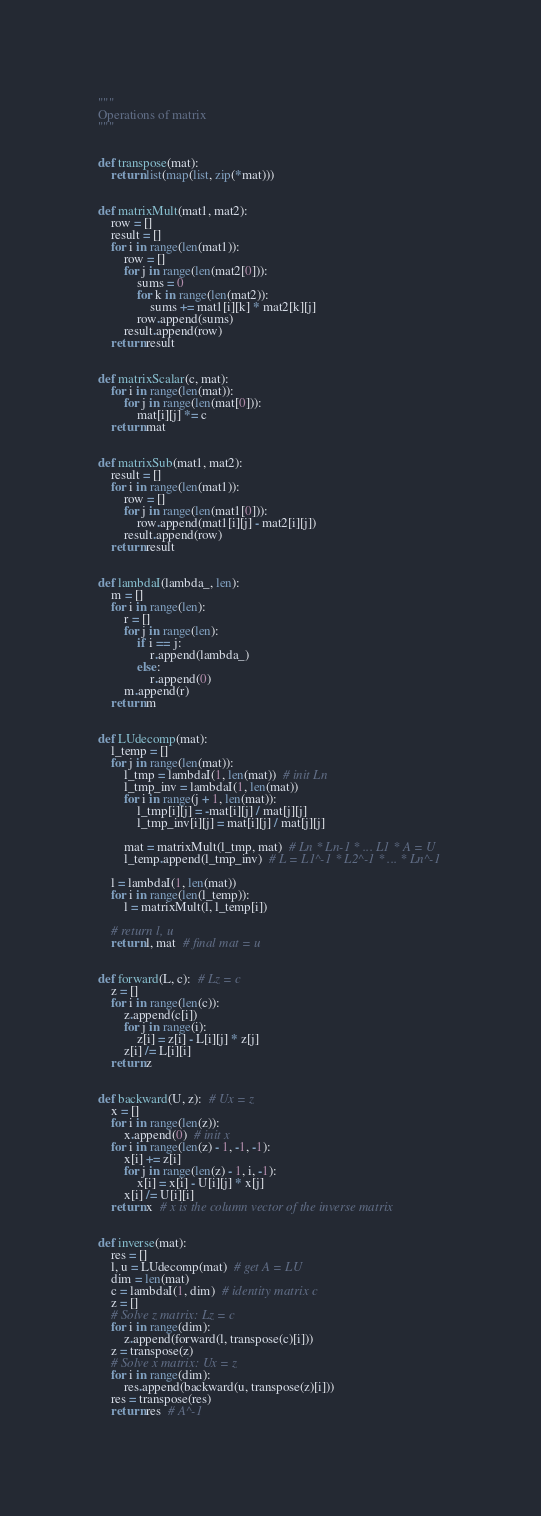<code> <loc_0><loc_0><loc_500><loc_500><_Python_>"""
Operations of matrix
"""


def transpose(mat):
    return list(map(list, zip(*mat)))


def matrixMult(mat1, mat2):
    row = []
    result = []
    for i in range(len(mat1)):
        row = []
        for j in range(len(mat2[0])):
            sums = 0
            for k in range(len(mat2)):
                sums += mat1[i][k] * mat2[k][j]
            row.append(sums)
        result.append(row)
    return result


def matrixScalar(c, mat):
    for i in range(len(mat)):
        for j in range(len(mat[0])):
            mat[i][j] *= c
    return mat


def matrixSub(mat1, mat2):
    result = []
    for i in range(len(mat1)):
        row = []
        for j in range(len(mat1[0])):
            row.append(mat1[i][j] - mat2[i][j])
        result.append(row)
    return result


def lambdaI(lambda_, len):
    m = []
    for i in range(len):
        r = []
        for j in range(len):
            if i == j:
                r.append(lambda_)
            else:
                r.append(0)
        m.append(r)
    return m


def LUdecomp(mat):
    l_temp = []
    for j in range(len(mat)):
        l_tmp = lambdaI(1, len(mat))  # init Ln
        l_tmp_inv = lambdaI(1, len(mat))
        for i in range(j + 1, len(mat)):
            l_tmp[i][j] = -mat[i][j] / mat[j][j]
            l_tmp_inv[i][j] = mat[i][j] / mat[j][j]

        mat = matrixMult(l_tmp, mat)  # Ln * Ln-1 * ... L1 * A = U
        l_temp.append(l_tmp_inv)  # L = L1^-1 * L2^-1 * ... * Ln^-1

    l = lambdaI(1, len(mat))
    for i in range(len(l_temp)):
        l = matrixMult(l, l_temp[i])

    # return l, u
    return l, mat  # final mat = u


def forward(L, c):  # Lz = c
    z = []
    for i in range(len(c)):
        z.append(c[i])
        for j in range(i):
            z[i] = z[i] - L[i][j] * z[j]
        z[i] /= L[i][i]
    return z


def backward(U, z):  # Ux = z
    x = []
    for i in range(len(z)):
        x.append(0)  # init x
    for i in range(len(z) - 1, -1, -1):
        x[i] += z[i]
        for j in range(len(z) - 1, i, -1):
            x[i] = x[i] - U[i][j] * x[j]
        x[i] /= U[i][i]
    return x  # x is the column vector of the inverse matrix


def inverse(mat):
    res = []
    l, u = LUdecomp(mat)  # get A = LU
    dim = len(mat)
    c = lambdaI(1, dim)  # identity matrix c
    z = []
    # Solve z matrix: Lz = c
    for i in range(dim):
        z.append(forward(l, transpose(c)[i]))
    z = transpose(z)
    # Solve x matrix: Ux = z
    for i in range(dim):
        res.append(backward(u, transpose(z)[i]))
    res = transpose(res)
    return res  # A^-1
</code> 